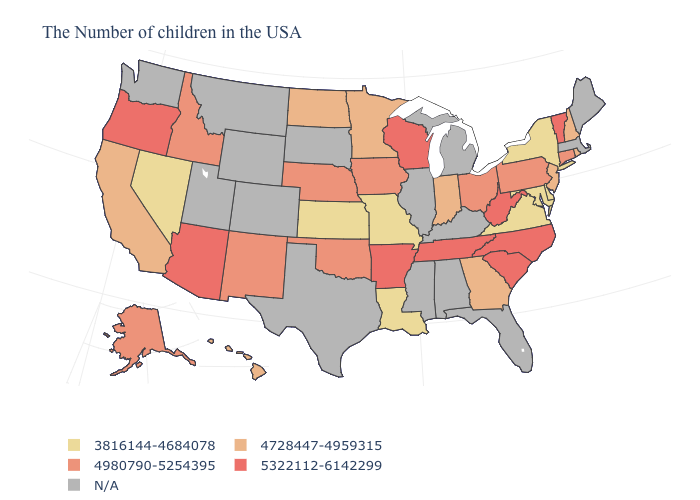Does the first symbol in the legend represent the smallest category?
Write a very short answer. Yes. What is the highest value in the MidWest ?
Short answer required. 5322112-6142299. Is the legend a continuous bar?
Keep it brief. No. Does Indiana have the highest value in the MidWest?
Give a very brief answer. No. Name the states that have a value in the range 4980790-5254395?
Be succinct. Connecticut, Pennsylvania, Ohio, Iowa, Nebraska, Oklahoma, New Mexico, Idaho, Alaska. What is the value of Iowa?
Keep it brief. 4980790-5254395. What is the lowest value in states that border Maryland?
Quick response, please. 3816144-4684078. What is the value of Georgia?
Short answer required. 4728447-4959315. Name the states that have a value in the range 4980790-5254395?
Answer briefly. Connecticut, Pennsylvania, Ohio, Iowa, Nebraska, Oklahoma, New Mexico, Idaho, Alaska. What is the value of North Carolina?
Give a very brief answer. 5322112-6142299. How many symbols are there in the legend?
Quick response, please. 5. Among the states that border Mississippi , does Arkansas have the lowest value?
Be succinct. No. What is the highest value in the USA?
Short answer required. 5322112-6142299. 